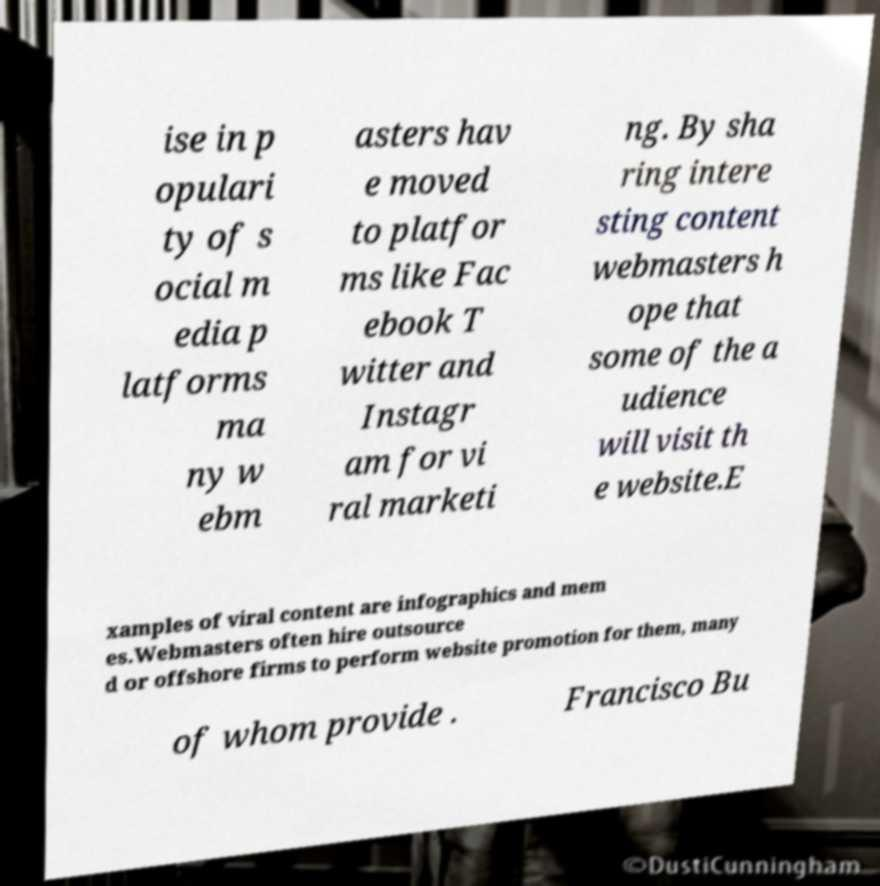I need the written content from this picture converted into text. Can you do that? ise in p opulari ty of s ocial m edia p latforms ma ny w ebm asters hav e moved to platfor ms like Fac ebook T witter and Instagr am for vi ral marketi ng. By sha ring intere sting content webmasters h ope that some of the a udience will visit th e website.E xamples of viral content are infographics and mem es.Webmasters often hire outsource d or offshore firms to perform website promotion for them, many of whom provide . Francisco Bu 